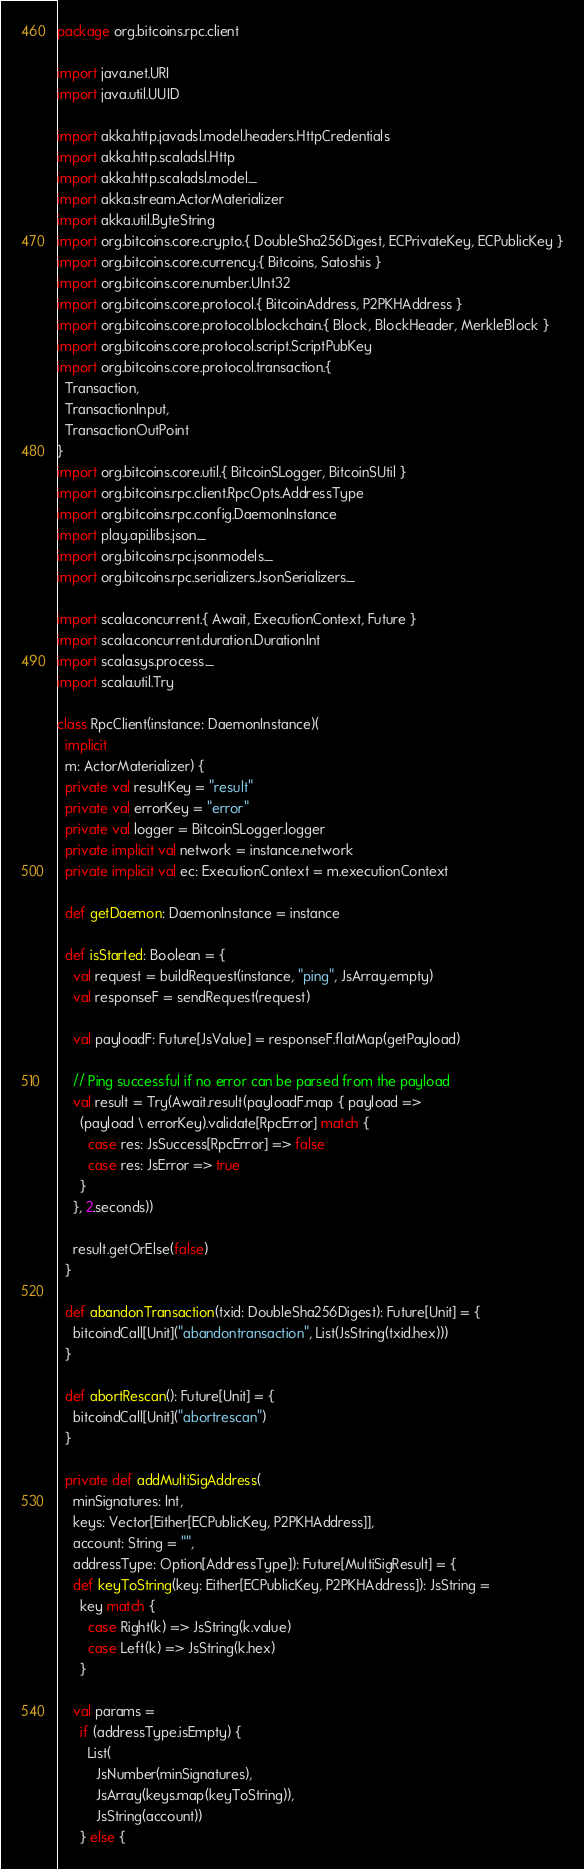<code> <loc_0><loc_0><loc_500><loc_500><_Scala_>package org.bitcoins.rpc.client

import java.net.URI
import java.util.UUID

import akka.http.javadsl.model.headers.HttpCredentials
import akka.http.scaladsl.Http
import akka.http.scaladsl.model._
import akka.stream.ActorMaterializer
import akka.util.ByteString
import org.bitcoins.core.crypto.{ DoubleSha256Digest, ECPrivateKey, ECPublicKey }
import org.bitcoins.core.currency.{ Bitcoins, Satoshis }
import org.bitcoins.core.number.UInt32
import org.bitcoins.core.protocol.{ BitcoinAddress, P2PKHAddress }
import org.bitcoins.core.protocol.blockchain.{ Block, BlockHeader, MerkleBlock }
import org.bitcoins.core.protocol.script.ScriptPubKey
import org.bitcoins.core.protocol.transaction.{
  Transaction,
  TransactionInput,
  TransactionOutPoint
}
import org.bitcoins.core.util.{ BitcoinSLogger, BitcoinSUtil }
import org.bitcoins.rpc.client.RpcOpts.AddressType
import org.bitcoins.rpc.config.DaemonInstance
import play.api.libs.json._
import org.bitcoins.rpc.jsonmodels._
import org.bitcoins.rpc.serializers.JsonSerializers._

import scala.concurrent.{ Await, ExecutionContext, Future }
import scala.concurrent.duration.DurationInt
import scala.sys.process._
import scala.util.Try

class RpcClient(instance: DaemonInstance)(
  implicit
  m: ActorMaterializer) {
  private val resultKey = "result"
  private val errorKey = "error"
  private val logger = BitcoinSLogger.logger
  private implicit val network = instance.network
  private implicit val ec: ExecutionContext = m.executionContext

  def getDaemon: DaemonInstance = instance

  def isStarted: Boolean = {
    val request = buildRequest(instance, "ping", JsArray.empty)
    val responseF = sendRequest(request)

    val payloadF: Future[JsValue] = responseF.flatMap(getPayload)

    // Ping successful if no error can be parsed from the payload
    val result = Try(Await.result(payloadF.map { payload =>
      (payload \ errorKey).validate[RpcError] match {
        case res: JsSuccess[RpcError] => false
        case res: JsError => true
      }
    }, 2.seconds))

    result.getOrElse(false)
  }

  def abandonTransaction(txid: DoubleSha256Digest): Future[Unit] = {
    bitcoindCall[Unit]("abandontransaction", List(JsString(txid.hex)))
  }

  def abortRescan(): Future[Unit] = {
    bitcoindCall[Unit]("abortrescan")
  }

  private def addMultiSigAddress(
    minSignatures: Int,
    keys: Vector[Either[ECPublicKey, P2PKHAddress]],
    account: String = "",
    addressType: Option[AddressType]): Future[MultiSigResult] = {
    def keyToString(key: Either[ECPublicKey, P2PKHAddress]): JsString =
      key match {
        case Right(k) => JsString(k.value)
        case Left(k) => JsString(k.hex)
      }

    val params =
      if (addressType.isEmpty) {
        List(
          JsNumber(minSignatures),
          JsArray(keys.map(keyToString)),
          JsString(account))
      } else {</code> 